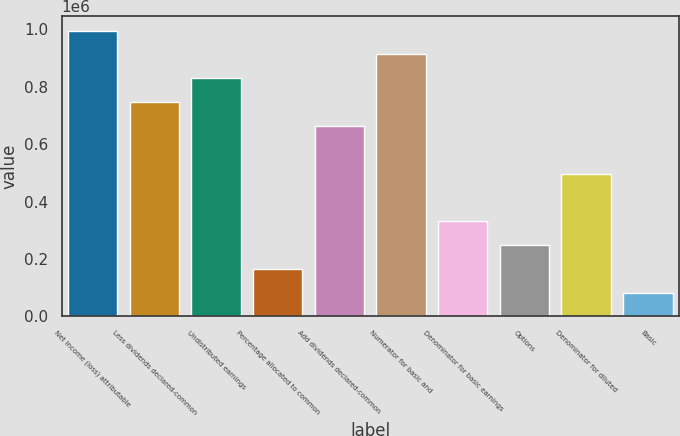Convert chart. <chart><loc_0><loc_0><loc_500><loc_500><bar_chart><fcel>Net income (loss) attributable<fcel>Less dividends declared-common<fcel>Undistributed earnings<fcel>Percentage allocated to common<fcel>Add dividends declared-common<fcel>Numerator for basic and<fcel>Denominator for basic earnings<fcel>Options<fcel>Denominator for diluted<fcel>Basic<nl><fcel>994742<fcel>746060<fcel>828954<fcel>165803<fcel>663166<fcel>911848<fcel>331591<fcel>248697<fcel>497379<fcel>82909.6<nl></chart> 